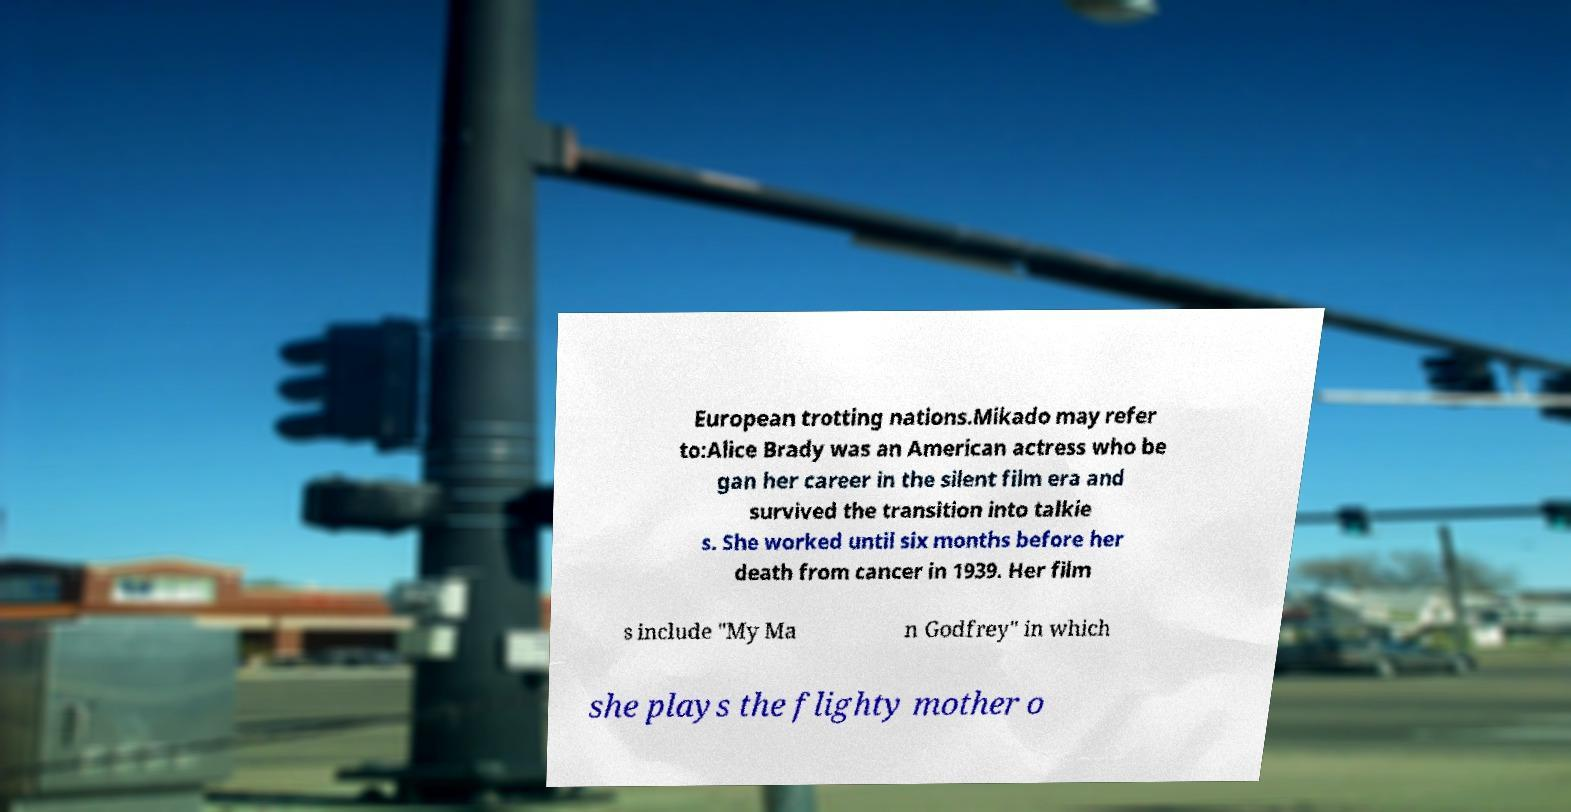Could you extract and type out the text from this image? European trotting nations.Mikado may refer to:Alice Brady was an American actress who be gan her career in the silent film era and survived the transition into talkie s. She worked until six months before her death from cancer in 1939. Her film s include "My Ma n Godfrey" in which she plays the flighty mother o 